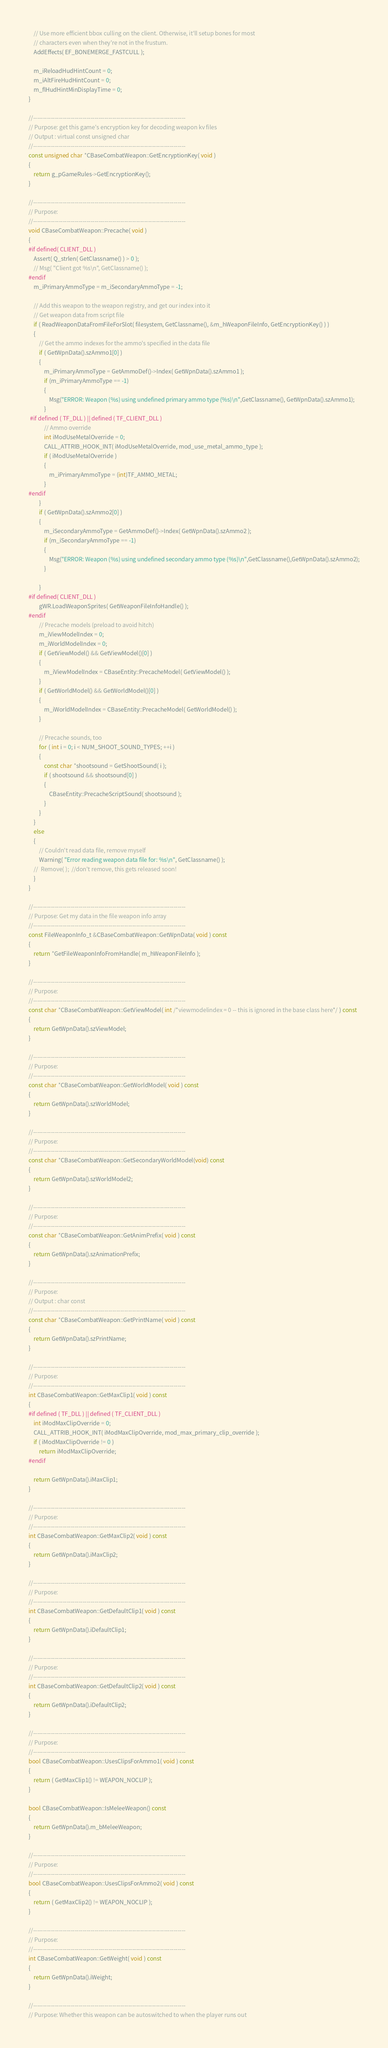Convert code to text. <code><loc_0><loc_0><loc_500><loc_500><_C++_>	// Use more efficient bbox culling on the client. Otherwise, it'll setup bones for most
	// characters even when they're not in the frustum.
	AddEffects( EF_BONEMERGE_FASTCULL );

	m_iReloadHudHintCount = 0;
	m_iAltFireHudHintCount = 0;
	m_flHudHintMinDisplayTime = 0;
}

//-----------------------------------------------------------------------------
// Purpose: get this game's encryption key for decoding weapon kv files
// Output : virtual const unsigned char
//-----------------------------------------------------------------------------
const unsigned char *CBaseCombatWeapon::GetEncryptionKey( void ) 
{ 
	return g_pGameRules->GetEncryptionKey(); 
}

//-----------------------------------------------------------------------------
// Purpose:
//-----------------------------------------------------------------------------
void CBaseCombatWeapon::Precache( void )
{
#if defined( CLIENT_DLL )
	Assert( Q_strlen( GetClassname() ) > 0 );
	// Msg( "Client got %s\n", GetClassname() );
#endif
	m_iPrimaryAmmoType = m_iSecondaryAmmoType = -1;

	// Add this weapon to the weapon registry, and get our index into it
	// Get weapon data from script file
	if ( ReadWeaponDataFromFileForSlot( filesystem, GetClassname(), &m_hWeaponFileInfo, GetEncryptionKey() ) )
	{
		// Get the ammo indexes for the ammo's specified in the data file
		if ( GetWpnData().szAmmo1[0] )
		{
			m_iPrimaryAmmoType = GetAmmoDef()->Index( GetWpnData().szAmmo1 );
			if (m_iPrimaryAmmoType == -1)
			{
				Msg("ERROR: Weapon (%s) using undefined primary ammo type (%s)\n",GetClassname(), GetWpnData().szAmmo1);
			}
 #if defined ( TF_DLL ) || defined ( TF_CLIENT_DLL )
			// Ammo override
			int iModUseMetalOverride = 0;
			CALL_ATTRIB_HOOK_INT( iModUseMetalOverride, mod_use_metal_ammo_type );
			if ( iModUseMetalOverride )
			{
				m_iPrimaryAmmoType = (int)TF_AMMO_METAL;
			}
#endif
 		}
		if ( GetWpnData().szAmmo2[0] )
		{
			m_iSecondaryAmmoType = GetAmmoDef()->Index( GetWpnData().szAmmo2 );
			if (m_iSecondaryAmmoType == -1)
			{
				Msg("ERROR: Weapon (%s) using undefined secondary ammo type (%s)\n",GetClassname(),GetWpnData().szAmmo2);
			}

		}
#if defined( CLIENT_DLL )
		gWR.LoadWeaponSprites( GetWeaponFileInfoHandle() );
#endif
		// Precache models (preload to avoid hitch)
		m_iViewModelIndex = 0;
		m_iWorldModelIndex = 0;
		if ( GetViewModel() && GetViewModel()[0] )
		{
			m_iViewModelIndex = CBaseEntity::PrecacheModel( GetViewModel() );
		}
		if ( GetWorldModel() && GetWorldModel()[0] )
		{
			m_iWorldModelIndex = CBaseEntity::PrecacheModel( GetWorldModel() );
		}

		// Precache sounds, too
		for ( int i = 0; i < NUM_SHOOT_SOUND_TYPES; ++i )
		{
			const char *shootsound = GetShootSound( i );
			if ( shootsound && shootsound[0] )
			{
				CBaseEntity::PrecacheScriptSound( shootsound );
			}
		}
	}
	else
	{
		// Couldn't read data file, remove myself
		Warning( "Error reading weapon data file for: %s\n", GetClassname() );
	//	Remove( );	//don't remove, this gets released soon!
	}
}

//-----------------------------------------------------------------------------
// Purpose: Get my data in the file weapon info array
//-----------------------------------------------------------------------------
const FileWeaponInfo_t &CBaseCombatWeapon::GetWpnData( void ) const
{
	return *GetFileWeaponInfoFromHandle( m_hWeaponFileInfo );
}

//-----------------------------------------------------------------------------
// Purpose: 
//-----------------------------------------------------------------------------
const char *CBaseCombatWeapon::GetViewModel( int /*viewmodelindex = 0 -- this is ignored in the base class here*/ ) const
{
	return GetWpnData().szViewModel;
}

//-----------------------------------------------------------------------------
// Purpose: 
//-----------------------------------------------------------------------------
const char *CBaseCombatWeapon::GetWorldModel( void ) const
{
	return GetWpnData().szWorldModel;
}

//-----------------------------------------------------------------------------
// Purpose: 
//-----------------------------------------------------------------------------
const char *CBaseCombatWeapon::GetSecondaryWorldModel(void) const
{
	return GetWpnData().szWorldModel2;
}

//-----------------------------------------------------------------------------
// Purpose: 
//-----------------------------------------------------------------------------
const char *CBaseCombatWeapon::GetAnimPrefix( void ) const
{
	return GetWpnData().szAnimationPrefix;
}

//-----------------------------------------------------------------------------
// Purpose: 
// Output : char const
//-----------------------------------------------------------------------------
const char *CBaseCombatWeapon::GetPrintName( void ) const
{
	return GetWpnData().szPrintName;
}

//-----------------------------------------------------------------------------
// Purpose: 
//-----------------------------------------------------------------------------
int CBaseCombatWeapon::GetMaxClip1( void ) const
{
#if defined ( TF_DLL ) || defined ( TF_CLIENT_DLL )
	int iModMaxClipOverride = 0;
	CALL_ATTRIB_HOOK_INT( iModMaxClipOverride, mod_max_primary_clip_override );
	if ( iModMaxClipOverride != 0 )
		return iModMaxClipOverride;
#endif

	return GetWpnData().iMaxClip1;
}

//-----------------------------------------------------------------------------
// Purpose: 
//-----------------------------------------------------------------------------
int CBaseCombatWeapon::GetMaxClip2( void ) const
{
	return GetWpnData().iMaxClip2;
}

//-----------------------------------------------------------------------------
// Purpose: 
//-----------------------------------------------------------------------------
int CBaseCombatWeapon::GetDefaultClip1( void ) const
{
	return GetWpnData().iDefaultClip1;
}

//-----------------------------------------------------------------------------
// Purpose: 
//-----------------------------------------------------------------------------
int CBaseCombatWeapon::GetDefaultClip2( void ) const
{
	return GetWpnData().iDefaultClip2;
}

//-----------------------------------------------------------------------------
// Purpose: 
//-----------------------------------------------------------------------------
bool CBaseCombatWeapon::UsesClipsForAmmo1( void ) const
{
	return ( GetMaxClip1() != WEAPON_NOCLIP );
}

bool CBaseCombatWeapon::IsMeleeWeapon() const
{
	return GetWpnData().m_bMeleeWeapon;
}

//-----------------------------------------------------------------------------
// Purpose: 
//-----------------------------------------------------------------------------
bool CBaseCombatWeapon::UsesClipsForAmmo2( void ) const
{
	return ( GetMaxClip2() != WEAPON_NOCLIP );
}

//-----------------------------------------------------------------------------
// Purpose: 
//-----------------------------------------------------------------------------
int CBaseCombatWeapon::GetWeight( void ) const
{
	return GetWpnData().iWeight;
}

//-----------------------------------------------------------------------------
// Purpose: Whether this weapon can be autoswitched to when the player runs out</code> 